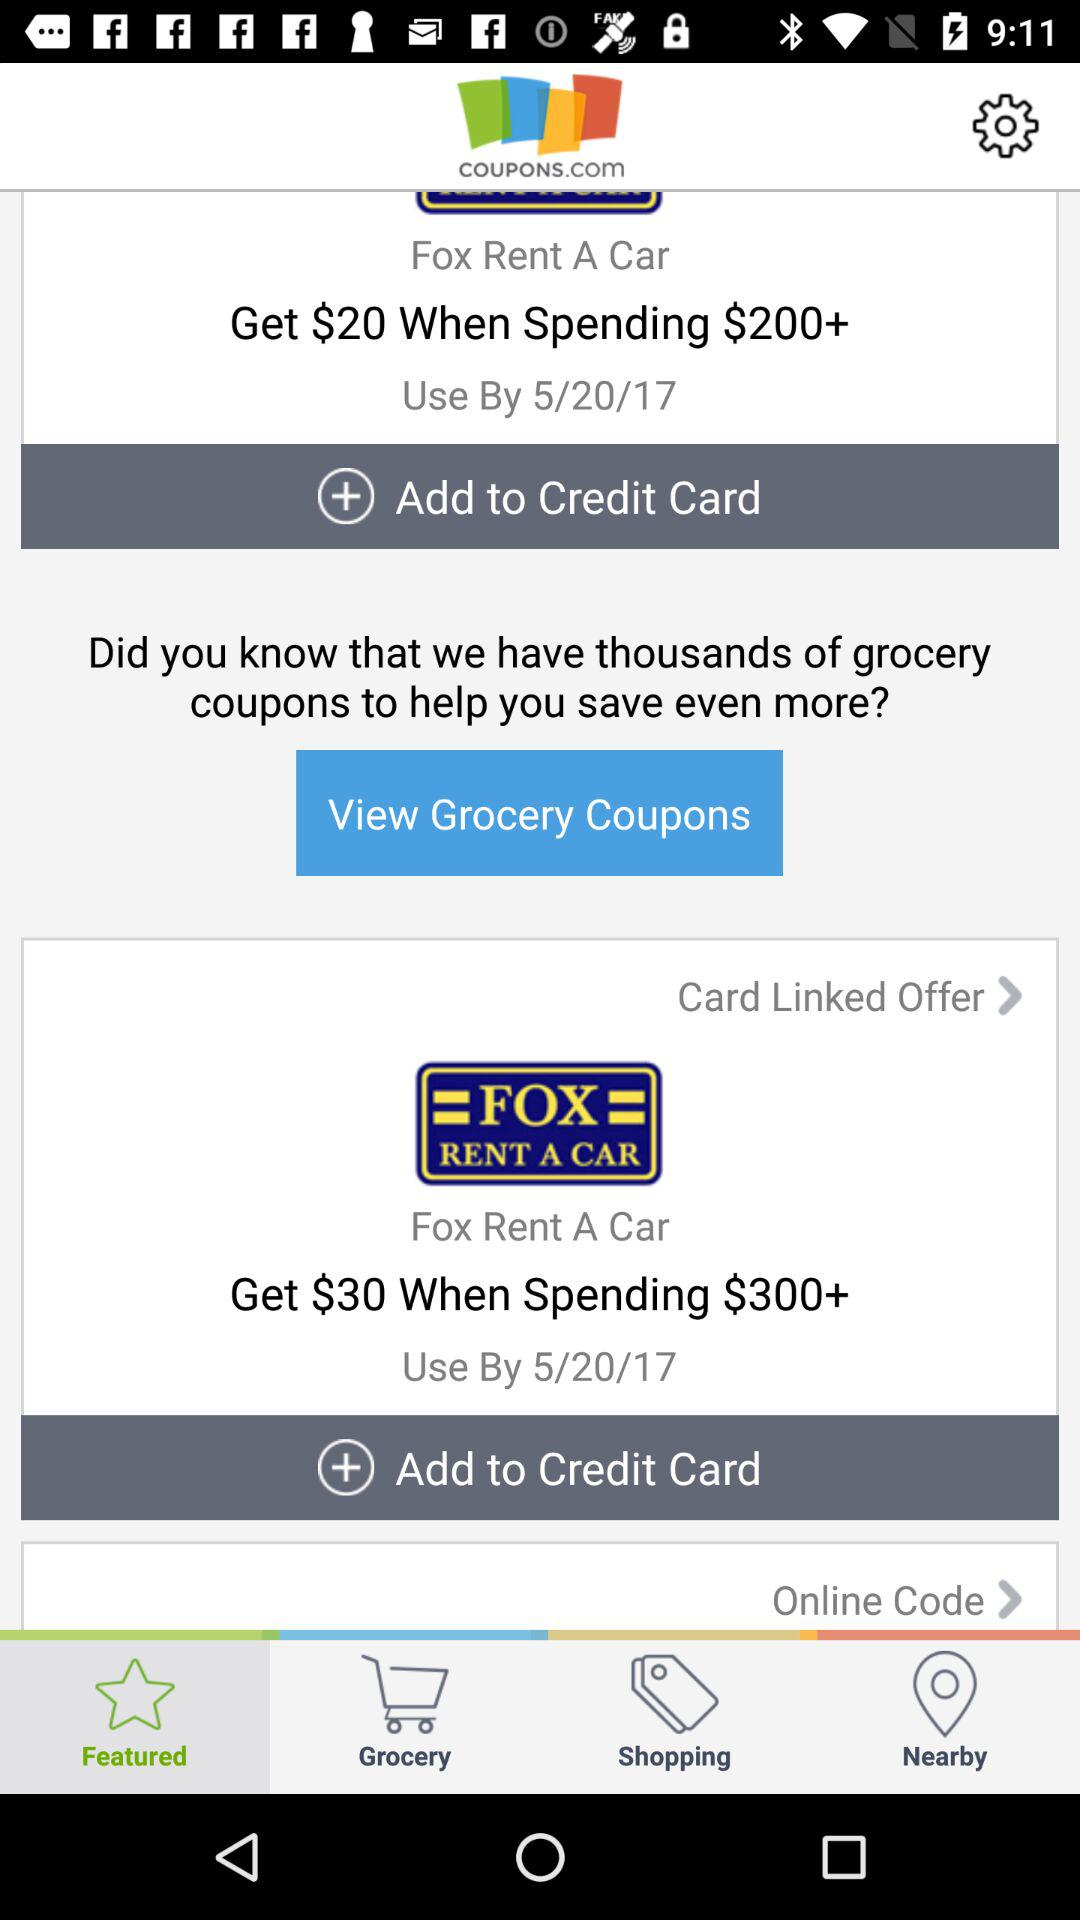How much we get after spending $200+? You get $20 after spending it. 